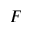Convert formula to latex. <formula><loc_0><loc_0><loc_500><loc_500>F</formula> 